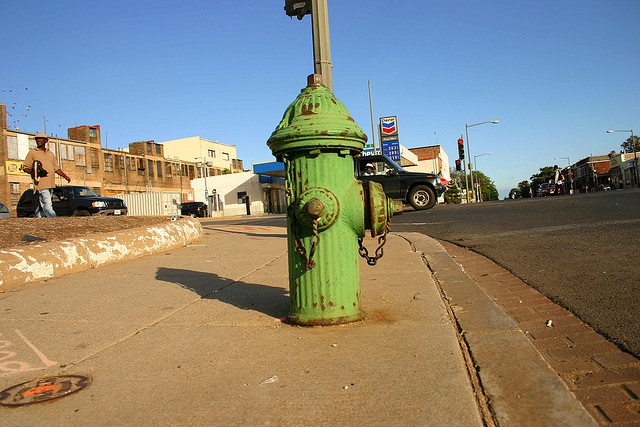Describe the objects in this image and their specific colors. I can see fire hydrant in gray, olive, black, and lightgreen tones, truck in gray, black, and maroon tones, truck in gray, black, olive, and maroon tones, people in gray, tan, black, and maroon tones, and truck in gray, black, and olive tones in this image. 